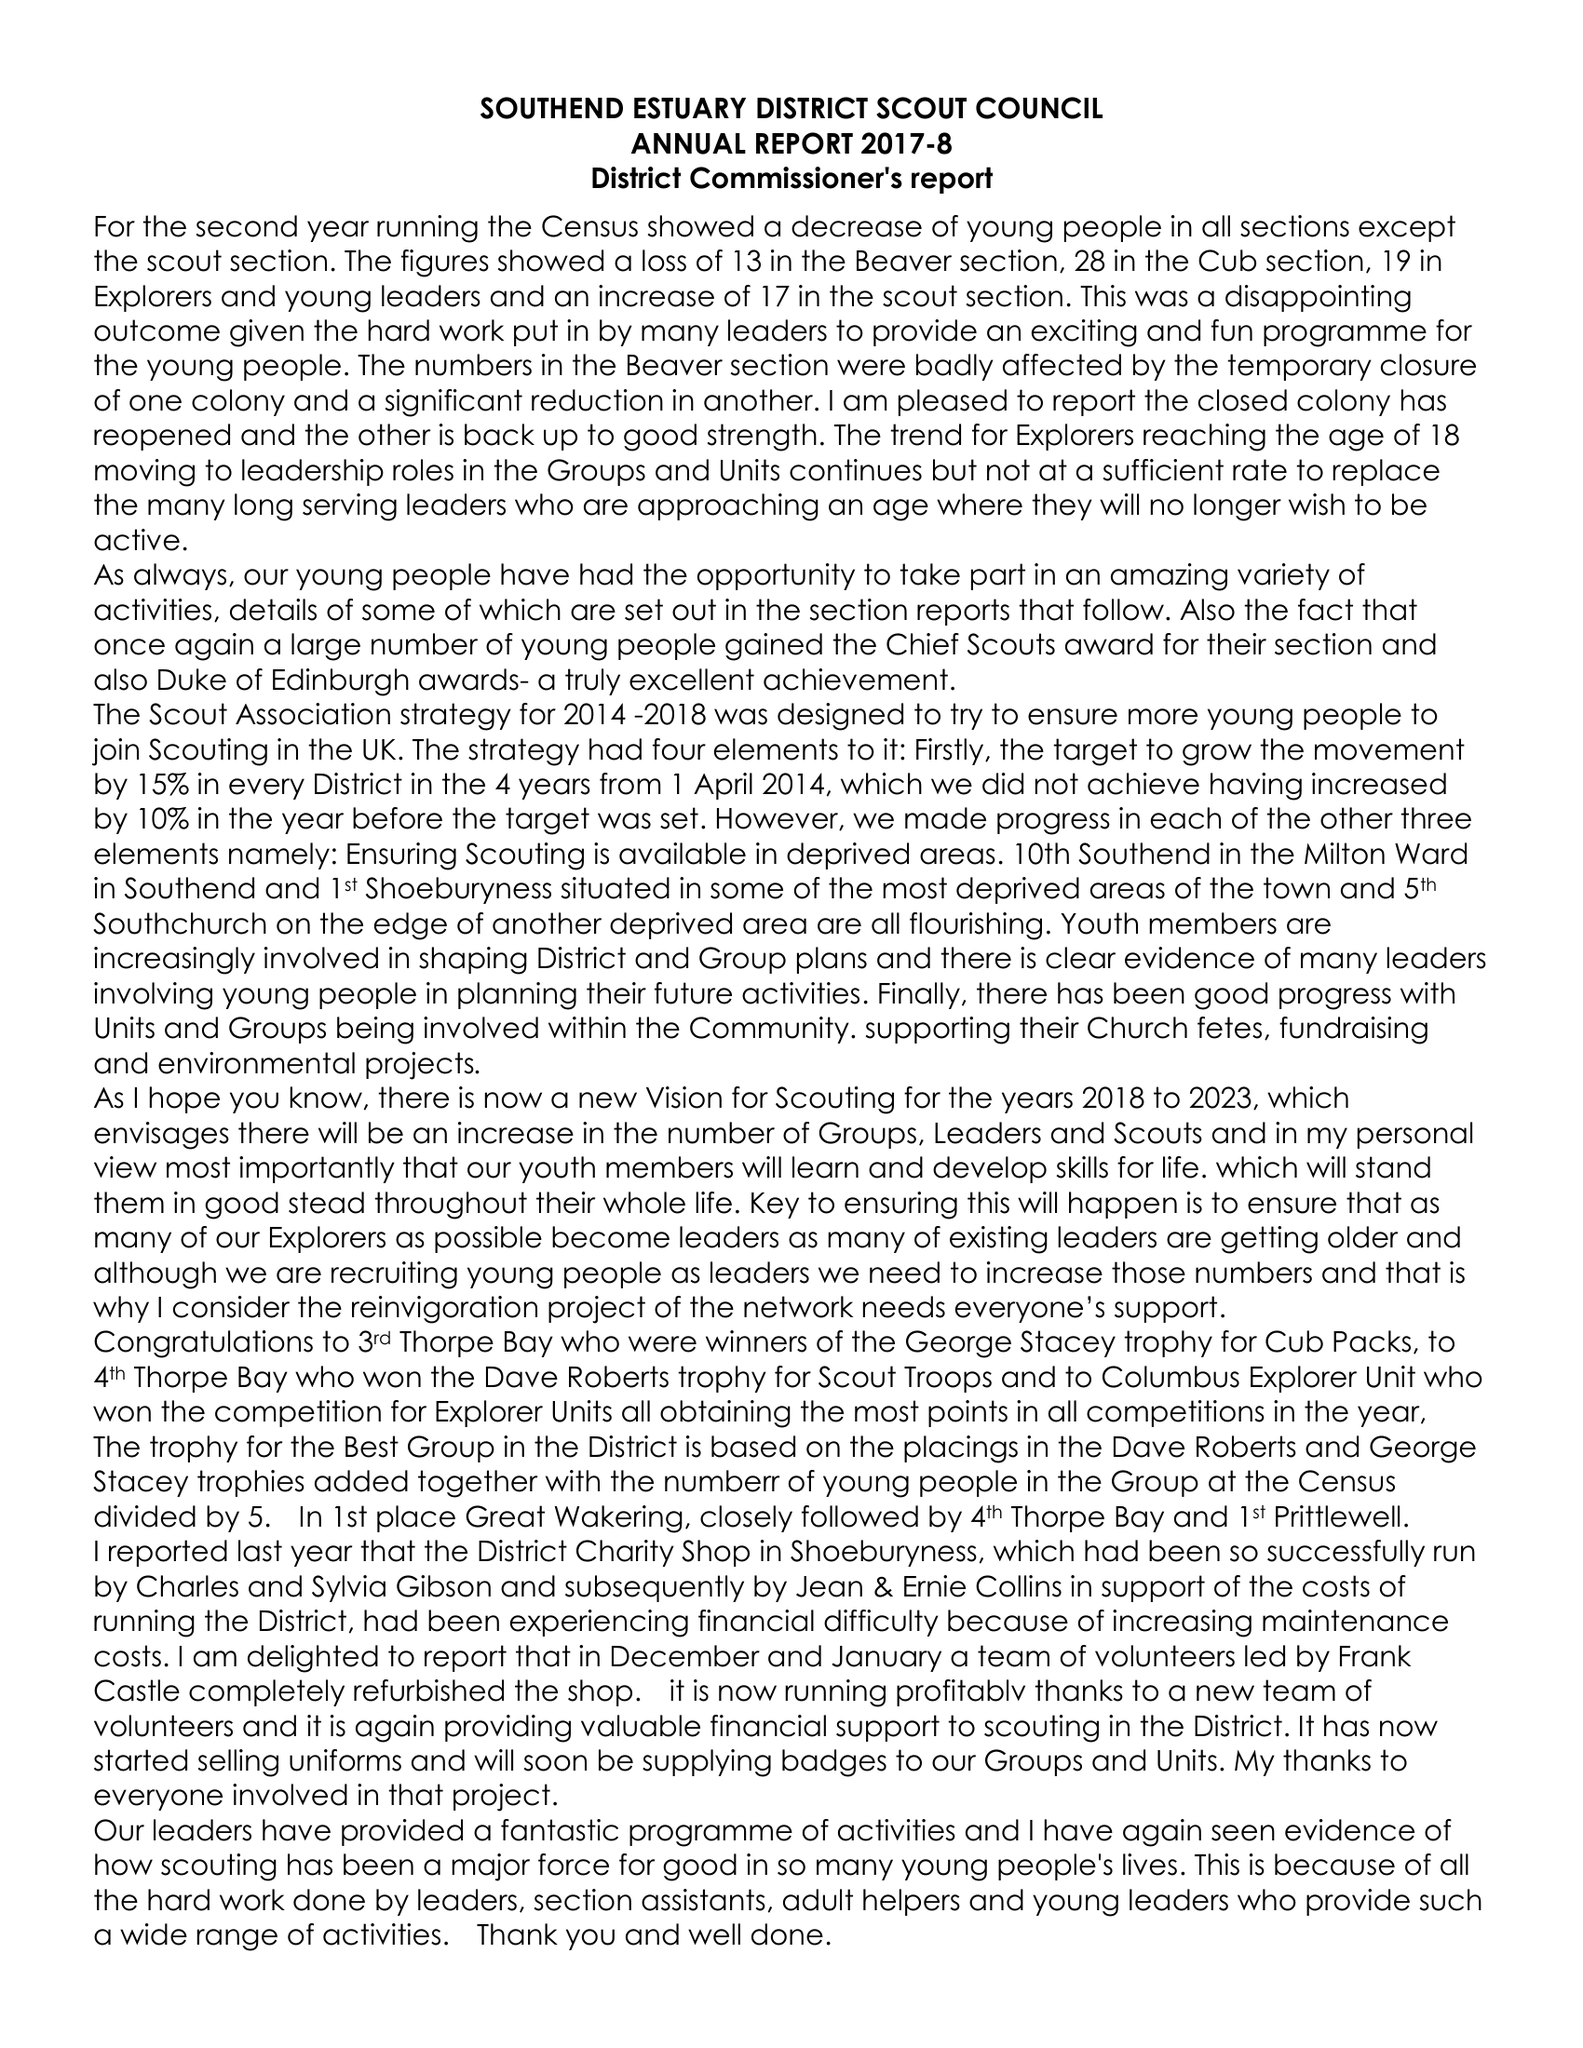What is the value for the charity_name?
Answer the question using a single word or phrase. Southend Estuary District Scout Council 